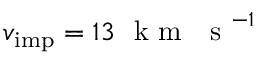Convert formula to latex. <formula><loc_0><loc_0><loc_500><loc_500>v _ { i m p } = 1 3 k m s ^ { - 1 }</formula> 